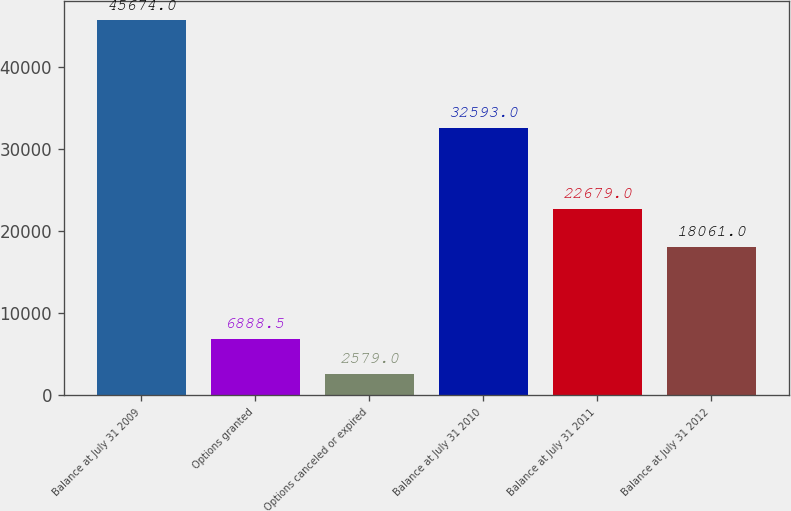<chart> <loc_0><loc_0><loc_500><loc_500><bar_chart><fcel>Balance at July 31 2009<fcel>Options granted<fcel>Options canceled or expired<fcel>Balance at July 31 2010<fcel>Balance at July 31 2011<fcel>Balance at July 31 2012<nl><fcel>45674<fcel>6888.5<fcel>2579<fcel>32593<fcel>22679<fcel>18061<nl></chart> 